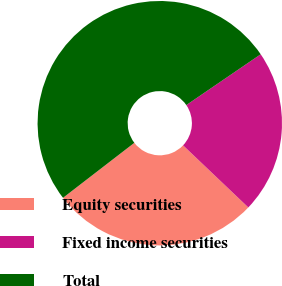<chart> <loc_0><loc_0><loc_500><loc_500><pie_chart><fcel>Equity securities<fcel>Fixed income securities<fcel>Total<nl><fcel>27.44%<fcel>21.64%<fcel>50.92%<nl></chart> 